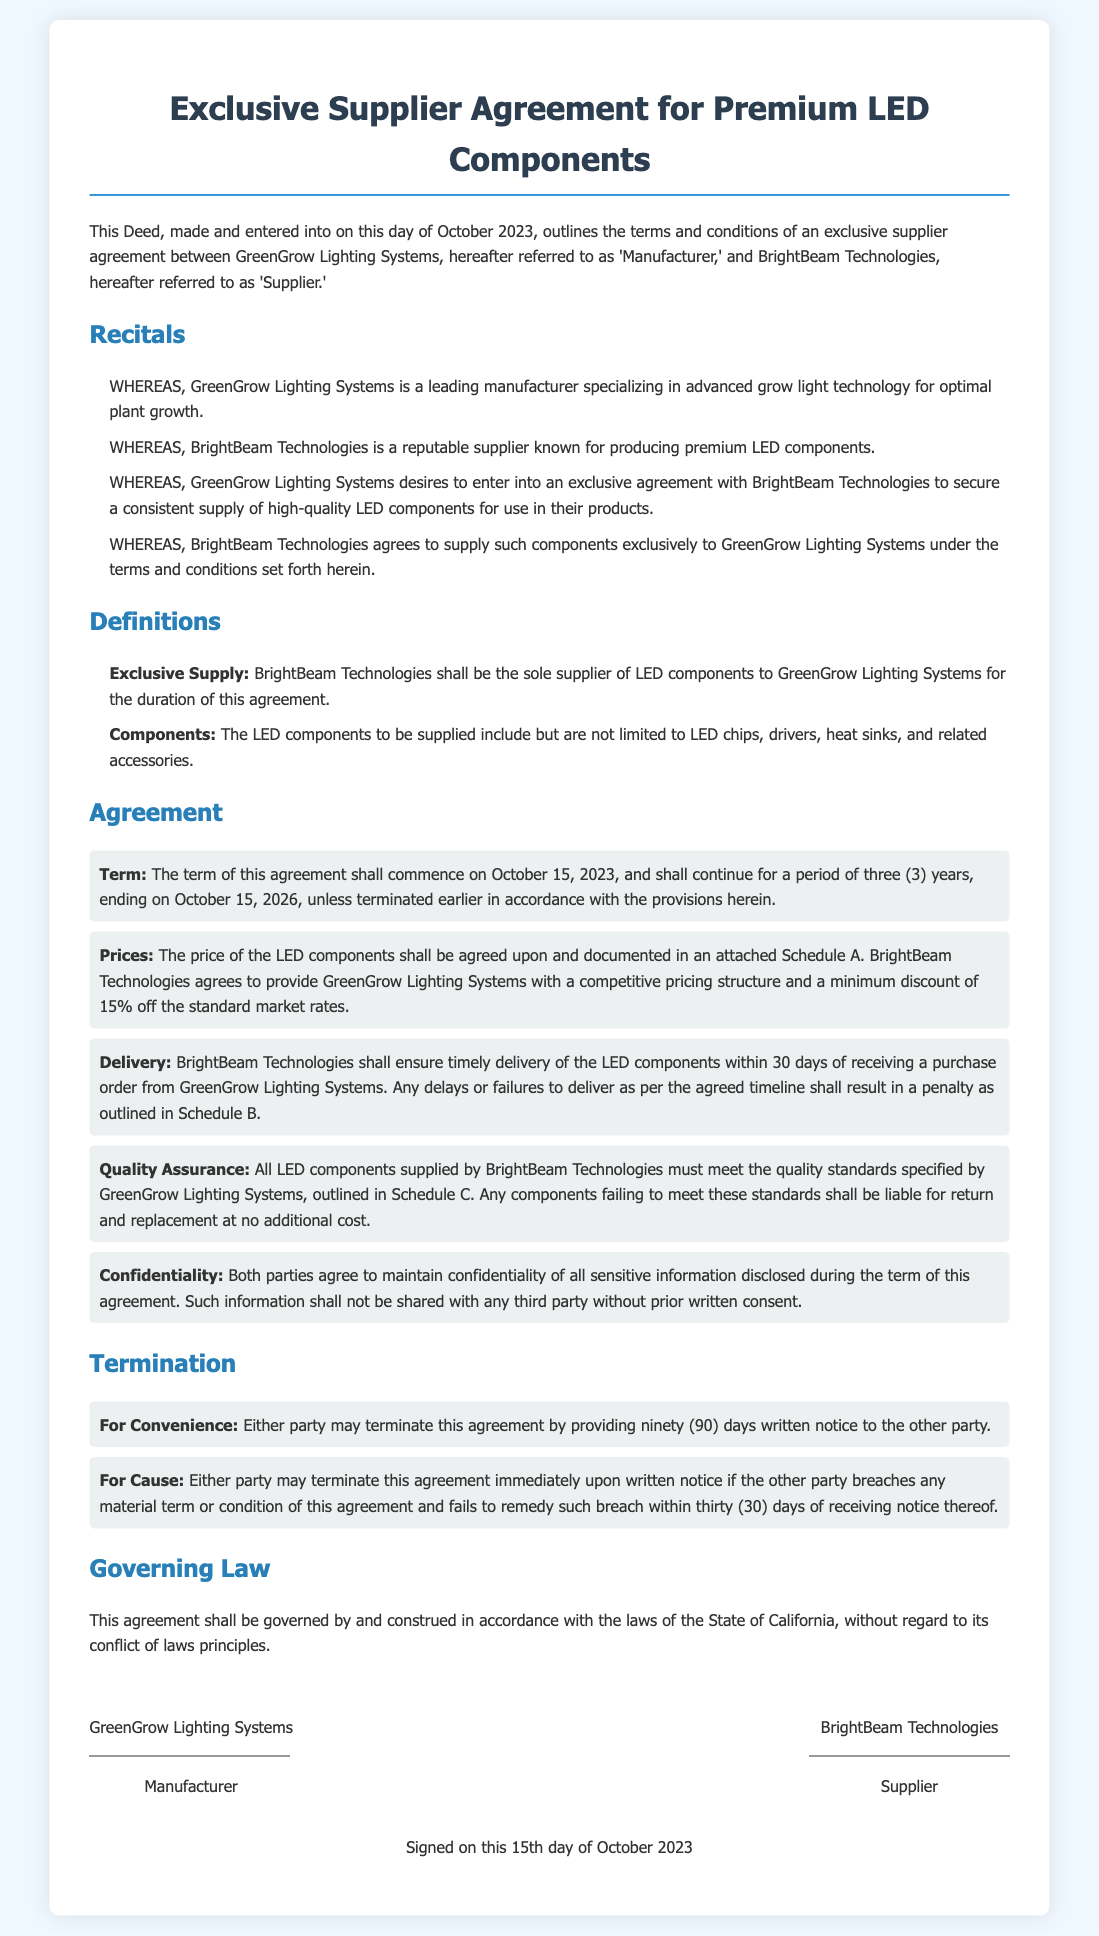What is the start date of the agreement? The agreement commences on October 15, 2023.
Answer: October 15, 2023 Who are the parties involved in the agreement? The parties are GreenGrow Lighting Systems and BrightBeam Technologies.
Answer: GreenGrow Lighting Systems and BrightBeam Technologies What is the duration of the agreement? The agreement lasts for a period of three (3) years.
Answer: three (3) years What is the minimum discount on components? BrightBeam Technologies agrees to provide a minimum discount of 15%.
Answer: 15% What must BrightBeam Technologies ensure regarding delivery? BrightBeam Technologies must ensure timely delivery within 30 days of receiving a purchase order.
Answer: within 30 days What happens if quality standards are not met? Components failing to meet the standards shall be liable for return and replacement.
Answer: return and replacement What is required for either party to terminate the agreement for convenience? Either party must provide ninety (90) days written notice.
Answer: ninety (90) days written notice What governing law is applicable to this agreement? The governing law for this agreement is the laws of the State of California.
Answer: State of California What is the title of the document? The title of the document is Exclusive Supplier Agreement for Premium LED Components.
Answer: Exclusive Supplier Agreement for Premium LED Components 